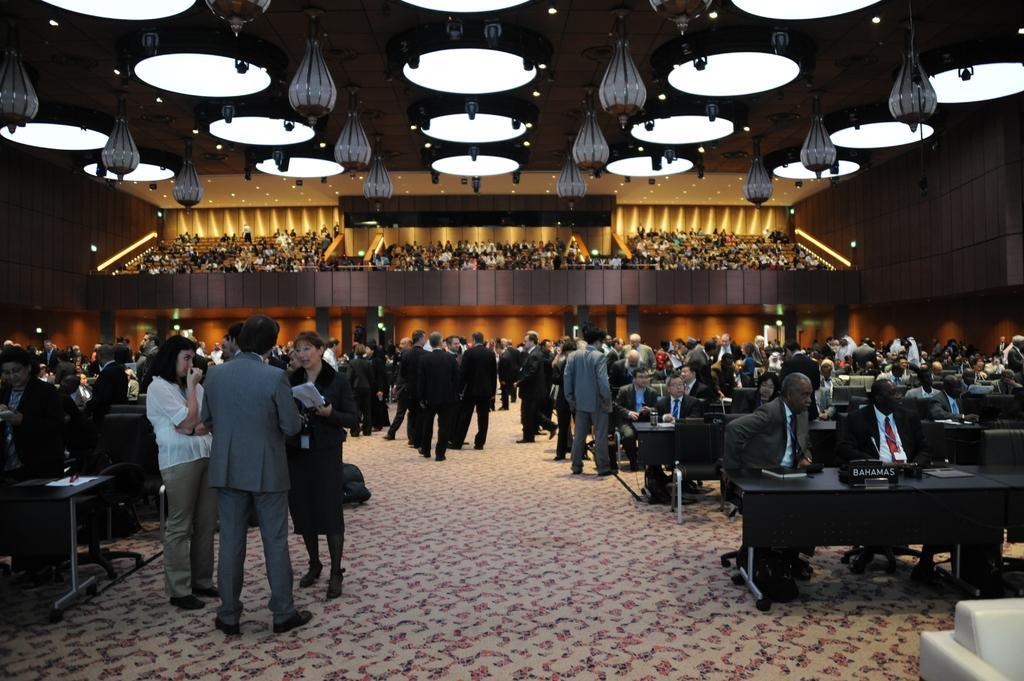Describe this image in one or two sentences. In this image there are group of people sitting in chair , another group of people standing , there are table, chair , lights, and carpet. 